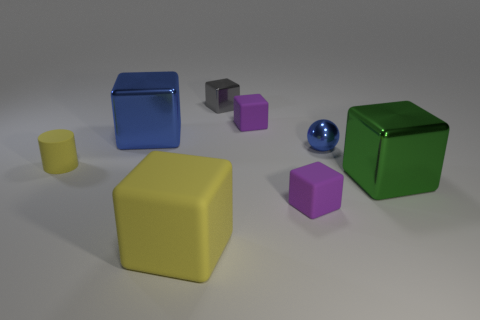Subtract all blue cubes. How many cubes are left? 5 Add 2 tiny yellow metal cylinders. How many objects exist? 10 Subtract all gray cubes. How many cubes are left? 5 Add 2 metallic blocks. How many metallic blocks are left? 5 Add 8 green metal cubes. How many green metal cubes exist? 9 Subtract 1 blue spheres. How many objects are left? 7 Subtract all cubes. How many objects are left? 2 Subtract 1 cubes. How many cubes are left? 5 Subtract all green balls. Subtract all red cylinders. How many balls are left? 1 Subtract all brown cylinders. How many gray cubes are left? 1 